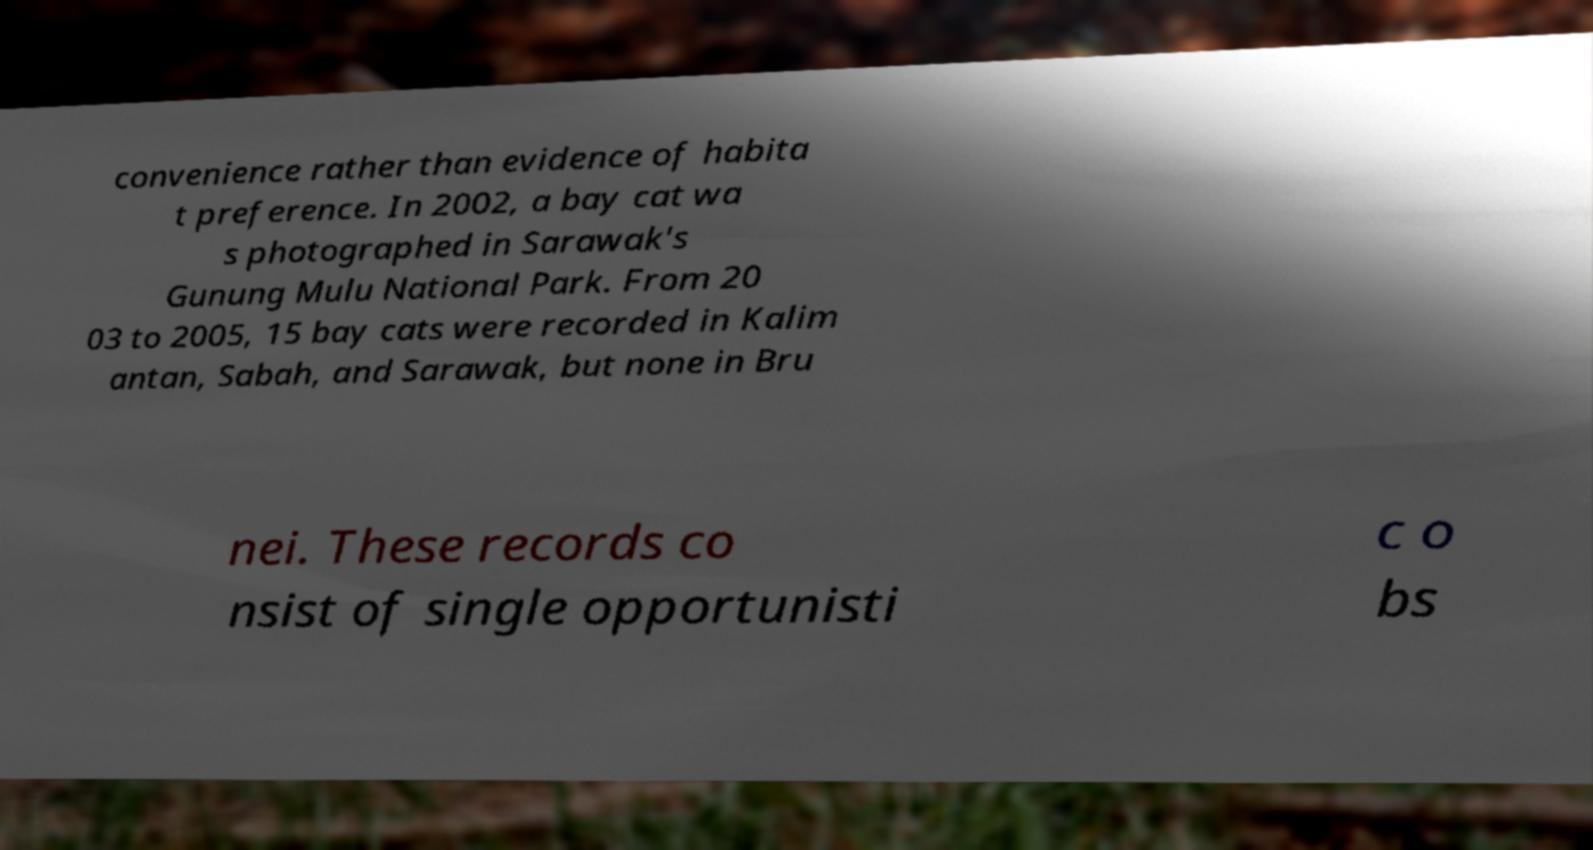Please identify and transcribe the text found in this image. convenience rather than evidence of habita t preference. In 2002, a bay cat wa s photographed in Sarawak's Gunung Mulu National Park. From 20 03 to 2005, 15 bay cats were recorded in Kalim antan, Sabah, and Sarawak, but none in Bru nei. These records co nsist of single opportunisti c o bs 